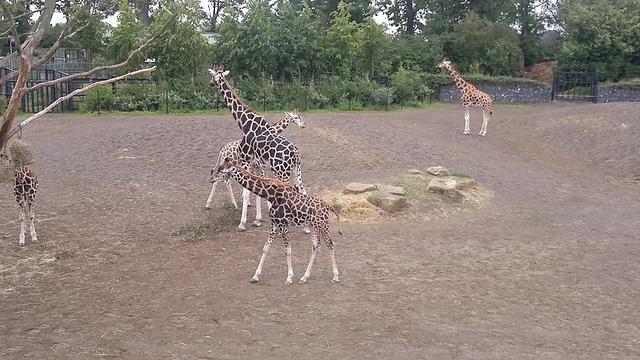What do these animals have?
Select the accurate answer and provide explanation: 'Answer: answer
Rationale: rationale.'
Options: Long necks, wings, horns, talons. Answer: long necks.
Rationale: They have long necks 